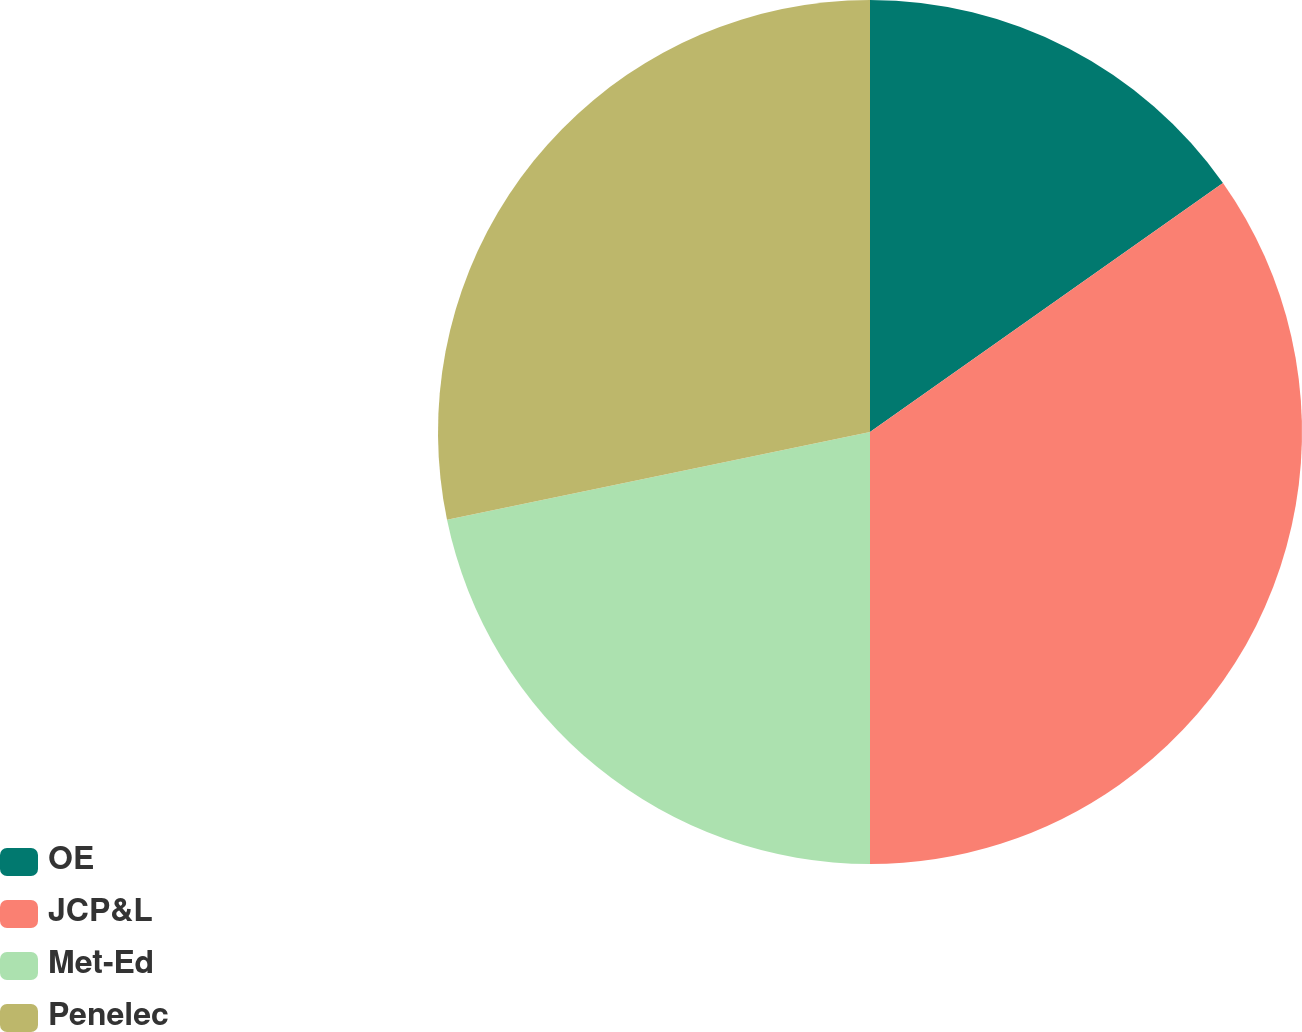Convert chart. <chart><loc_0><loc_0><loc_500><loc_500><pie_chart><fcel>OE<fcel>JCP&L<fcel>Met-Ed<fcel>Penelec<nl><fcel>15.22%<fcel>34.78%<fcel>21.74%<fcel>28.26%<nl></chart> 